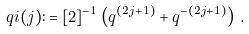<formula> <loc_0><loc_0><loc_500><loc_500>\ q i ( j ) \colon = [ 2 ] ^ { - 1 } \left ( q ^ { ( 2 j + 1 ) } + q ^ { - ( 2 j + 1 ) } \right ) \, .</formula> 